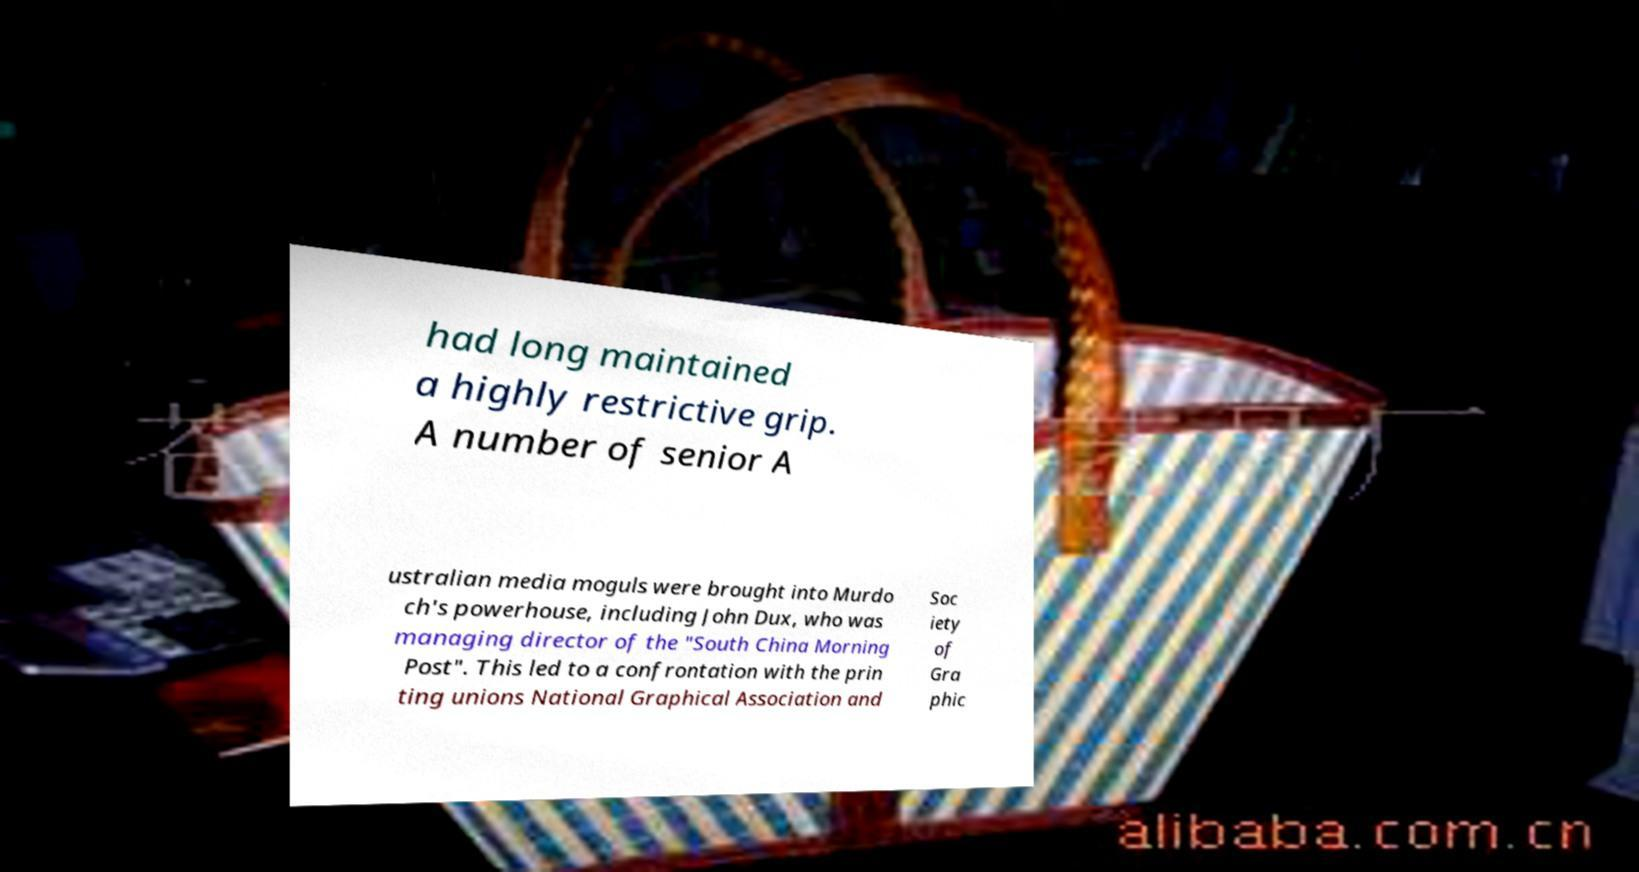Could you assist in decoding the text presented in this image and type it out clearly? had long maintained a highly restrictive grip. A number of senior A ustralian media moguls were brought into Murdo ch's powerhouse, including John Dux, who was managing director of the "South China Morning Post". This led to a confrontation with the prin ting unions National Graphical Association and Soc iety of Gra phic 